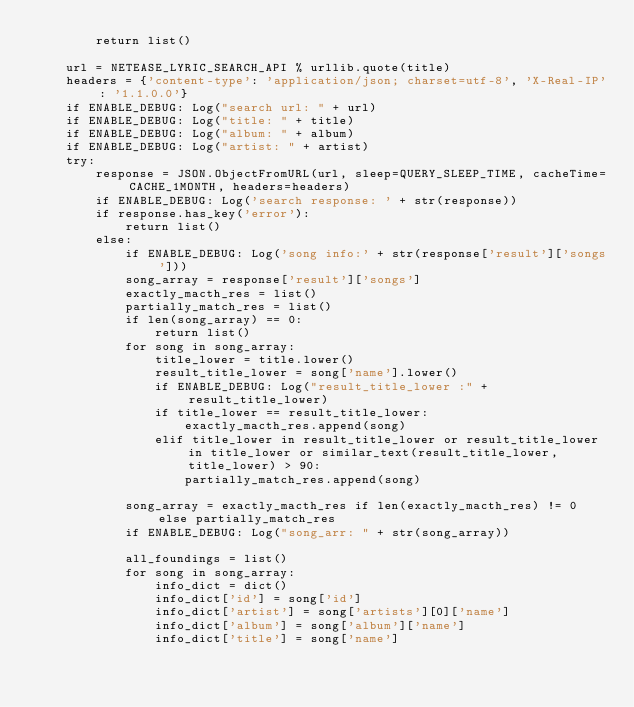Convert code to text. <code><loc_0><loc_0><loc_500><loc_500><_Python_>        return list()

    url = NETEASE_LYRIC_SEARCH_API % urllib.quote(title)
    headers = {'content-type': 'application/json; charset=utf-8', 'X-Real-IP': '1.1.0.0'}
    if ENABLE_DEBUG: Log("search url: " + url)
    if ENABLE_DEBUG: Log("title: " + title)
    if ENABLE_DEBUG: Log("album: " + album)
    if ENABLE_DEBUG: Log("artist: " + artist)
    try:
        response = JSON.ObjectFromURL(url, sleep=QUERY_SLEEP_TIME, cacheTime=CACHE_1MONTH, headers=headers)
        if ENABLE_DEBUG: Log('search response: ' + str(response))
        if response.has_key('error'):
            return list()            
        else:
            if ENABLE_DEBUG: Log('song info:' + str(response['result']['songs']))
            song_array = response['result']['songs']
            exactly_macth_res = list()
            partially_match_res = list()
            if len(song_array) == 0:
                return list()
            for song in song_array:
                title_lower = title.lower()
                result_title_lower = song['name'].lower()
                if ENABLE_DEBUG: Log("result_title_lower :" + result_title_lower)
                if title_lower == result_title_lower:
                    exactly_macth_res.append(song)
                elif title_lower in result_title_lower or result_title_lower in title_lower or similar_text(result_title_lower, title_lower) > 90:
                    partially_match_res.append(song)
            
            song_array = exactly_macth_res if len(exactly_macth_res) != 0 else partially_match_res
            if ENABLE_DEBUG: Log("song_arr: " + str(song_array))

            all_foundings = list()
            for song in song_array:
                info_dict = dict()
                info_dict['id'] = song['id']
                info_dict['artist'] = song['artists'][0]['name']
                info_dict['album'] = song['album']['name']
                info_dict['title'] = song['name']
</code> 